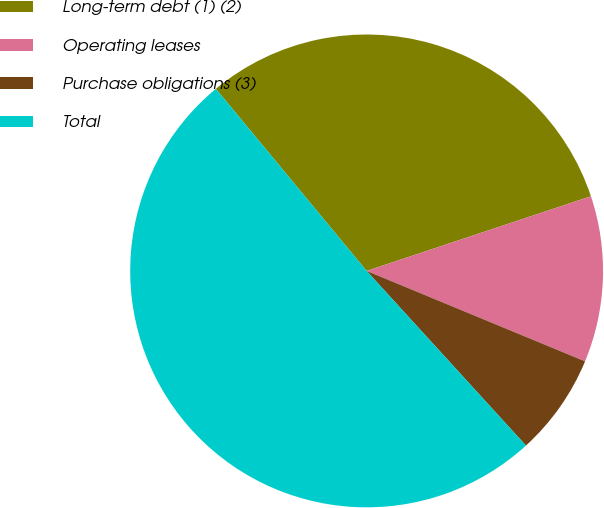Convert chart to OTSL. <chart><loc_0><loc_0><loc_500><loc_500><pie_chart><fcel>Long-term debt (1) (2)<fcel>Operating leases<fcel>Purchase obligations (3)<fcel>Total<nl><fcel>30.89%<fcel>11.36%<fcel>6.98%<fcel>50.76%<nl></chart> 